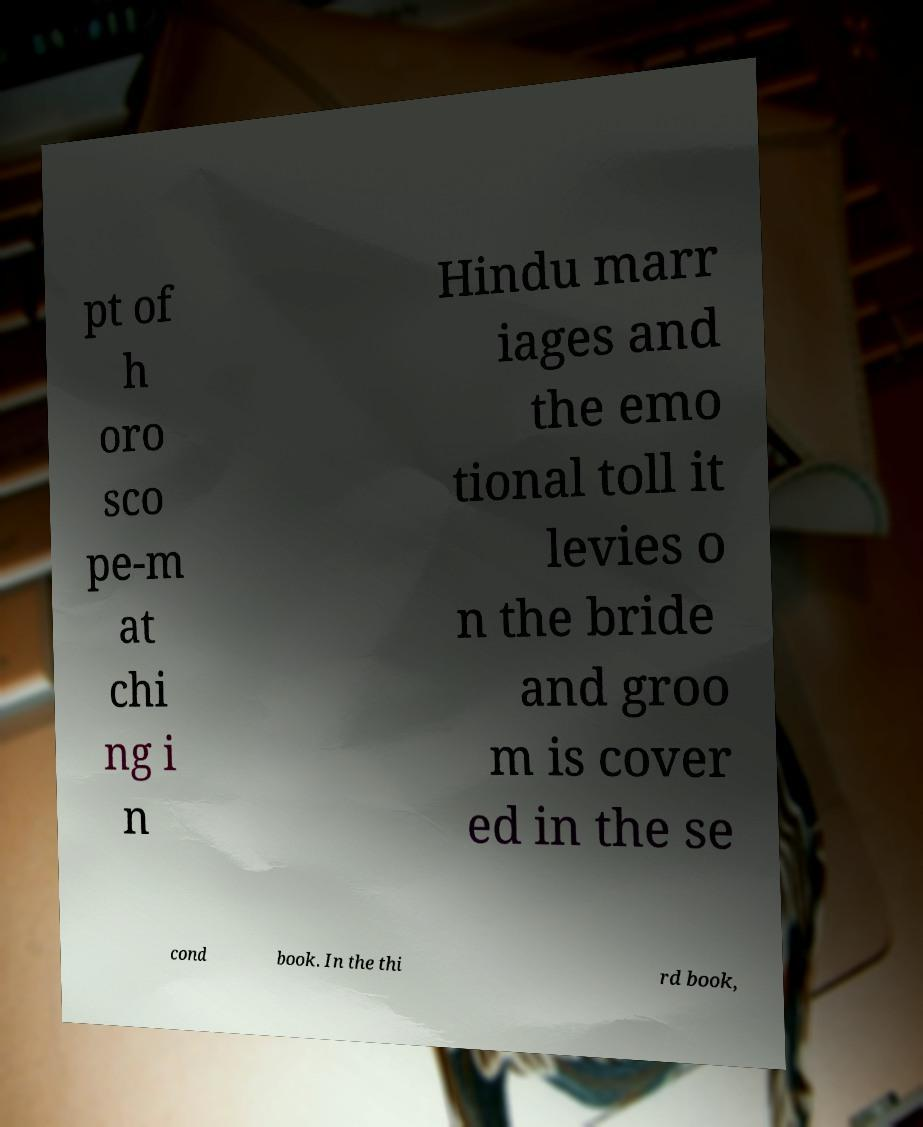What messages or text are displayed in this image? I need them in a readable, typed format. pt of h oro sco pe-m at chi ng i n Hindu marr iages and the emo tional toll it levies o n the bride and groo m is cover ed in the se cond book. In the thi rd book, 